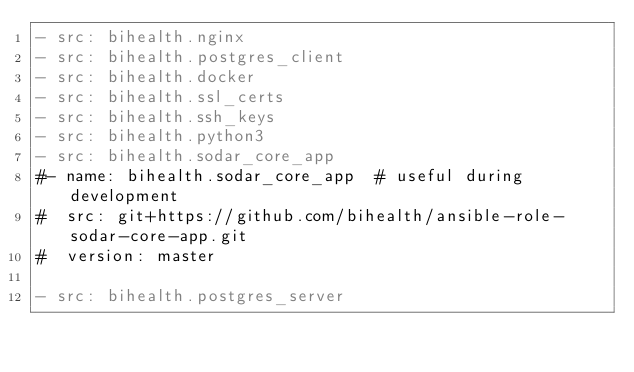<code> <loc_0><loc_0><loc_500><loc_500><_YAML_>- src: bihealth.nginx
- src: bihealth.postgres_client
- src: bihealth.docker
- src: bihealth.ssl_certs
- src: bihealth.ssh_keys
- src: bihealth.python3
- src: bihealth.sodar_core_app
#- name: bihealth.sodar_core_app  # useful during development
#  src: git+https://github.com/bihealth/ansible-role-sodar-core-app.git
#  version: master

- src: bihealth.postgres_server
</code> 